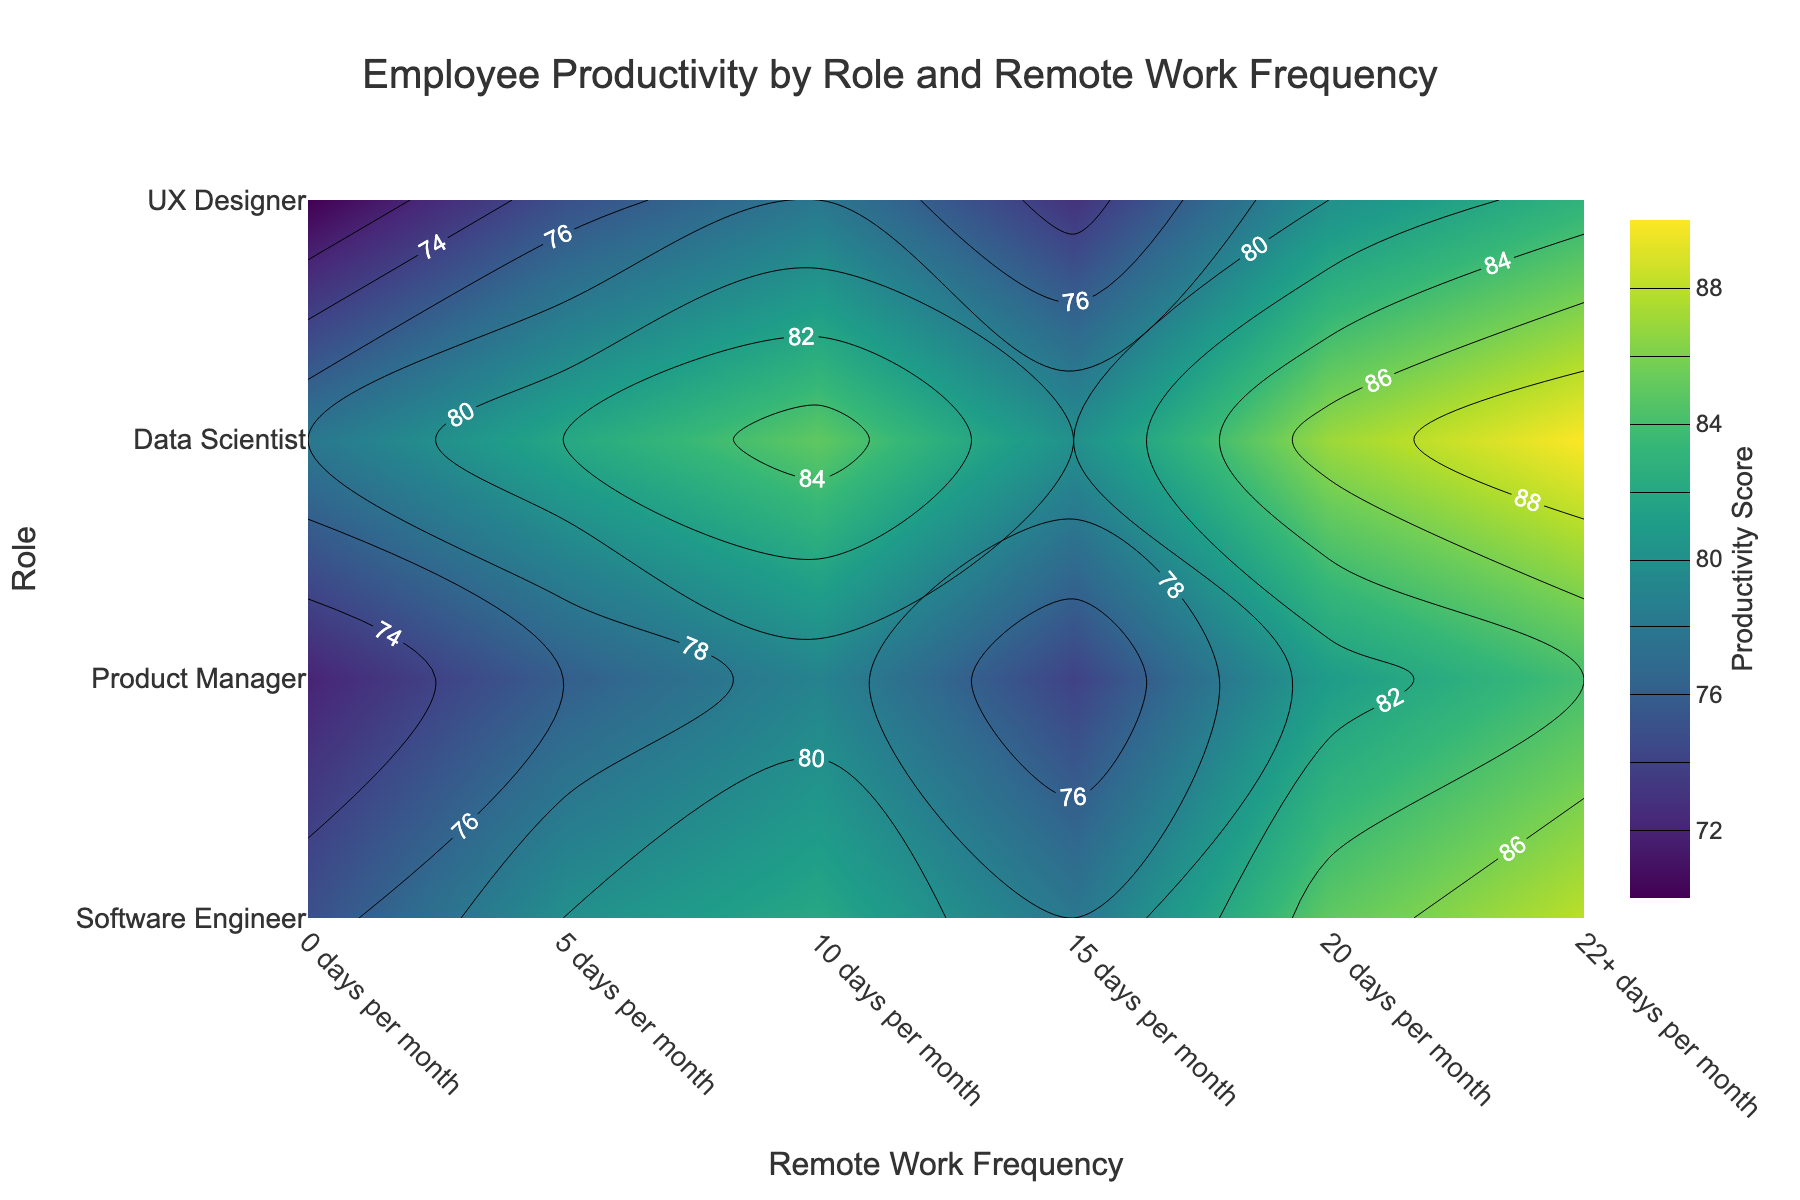What is the title of the plot? The title is displayed at the top center of the plot. It reads "Employee Productivity by Role and Remote Work Frequency".
Answer: Employee Productivity by Role and Remote Work Frequency What does the color scale represent in the plot? The color scale on the right side of the plot represents the "Productivity Score," with darker colors indicating lower productivity and lighter colors indicating higher productivity.
Answer: Productivity Score Which role has the highest productivity score, and at what remote work frequency? By examining the contour labels, the Data Scientist role at "22+ days per month" has the highest productivity score, represented by the lightest color and the highest label value.
Answer: Data Scientist, 22+ days per month What is the productivity score for a Software Engineer working remotely 10 days per month? Locate the Software Engineer row and the column corresponding to "10 days per month" to find the contour label, which shows a productivity score of 82.
Answer: 82 Which role shows the largest increase in productivity from 0 days to 22+ days per month of remote work? Compare the productivity scores at 0 days and 22+ days per month for all roles. The Software Engineer role increases from 75 to 88, resulting in the largest increase of 13 points.
Answer: Software Engineer What is the average productivity score for Product Managers across all remote work frequencies? Sum the productivity scores for Product Managers (72, 76, 79, 74, 81, 84) and divide by the number of frequencies (6): (72 + 76 + 79 + 74 + 81 + 84) / 6 = 466 / 6 = 77.67.
Answer: 77.67 How does the productivity score for a UX Designer working 15 days remotely compare to that of a Data Scientist working the same number of days? Locate both the UX Designer and Data Scientist rows at "15 days per month" remote work frequency and compare the productivity labels: UX Designer has 73, while Data Scientist has 80.
Answer: UX Designer: 73, Data Scientist: 80 Which remote work frequency consistently shows the highest productivity scores across all roles? Examine each remote work frequency column and identify the one with generally higher scores. "22+ days per month" consistently has the highest productivity scores for all roles.
Answer: 22+ days per month What is the average productivity score for all roles working remotely 20 days per month? Sum the productivity scores for each role at 20 days (85, 81, 87, 80) and divide by the number of roles (4): (85 + 81 + 87 + 80) / 4 = 333 / 4 = 83.25
Answer: 83.25 